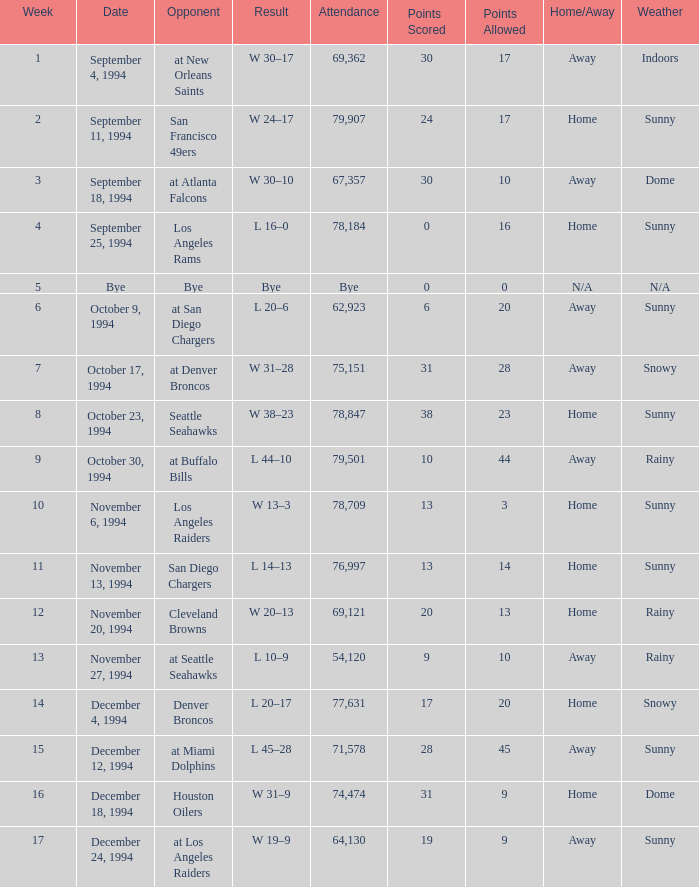What was the score of the Chiefs November 27, 1994 game? L 10–9. 